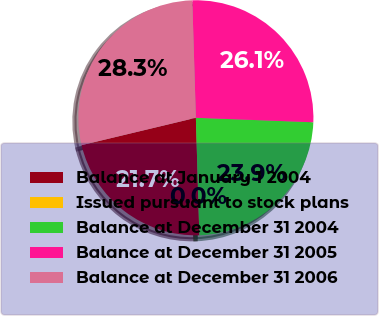<chart> <loc_0><loc_0><loc_500><loc_500><pie_chart><fcel>Balance at January 1 2004<fcel>Issued pursuant to stock plans<fcel>Balance at December 31 2004<fcel>Balance at December 31 2005<fcel>Balance at December 31 2006<nl><fcel>21.73%<fcel>0.01%<fcel>23.91%<fcel>26.09%<fcel>28.26%<nl></chart> 